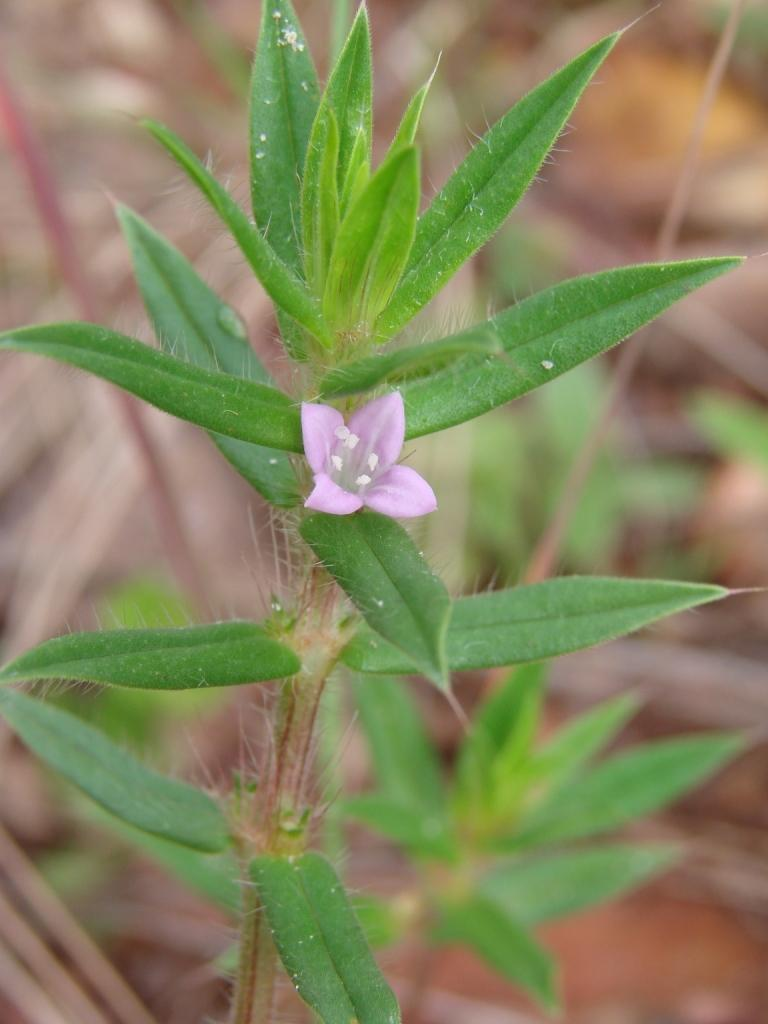What type of plant is visible in the image? There is a flower in the image, which is a type of plant. Can you describe the flower in the image? Unfortunately, the facts provided do not give enough detail to describe the flower. What color is the crayon being used to draw the flower in the image? There is no crayon or drawing present in the image; it features a flower and a plant. How many girls are visible in the image? There is no girl present in the image; it features a flower and a plant. 